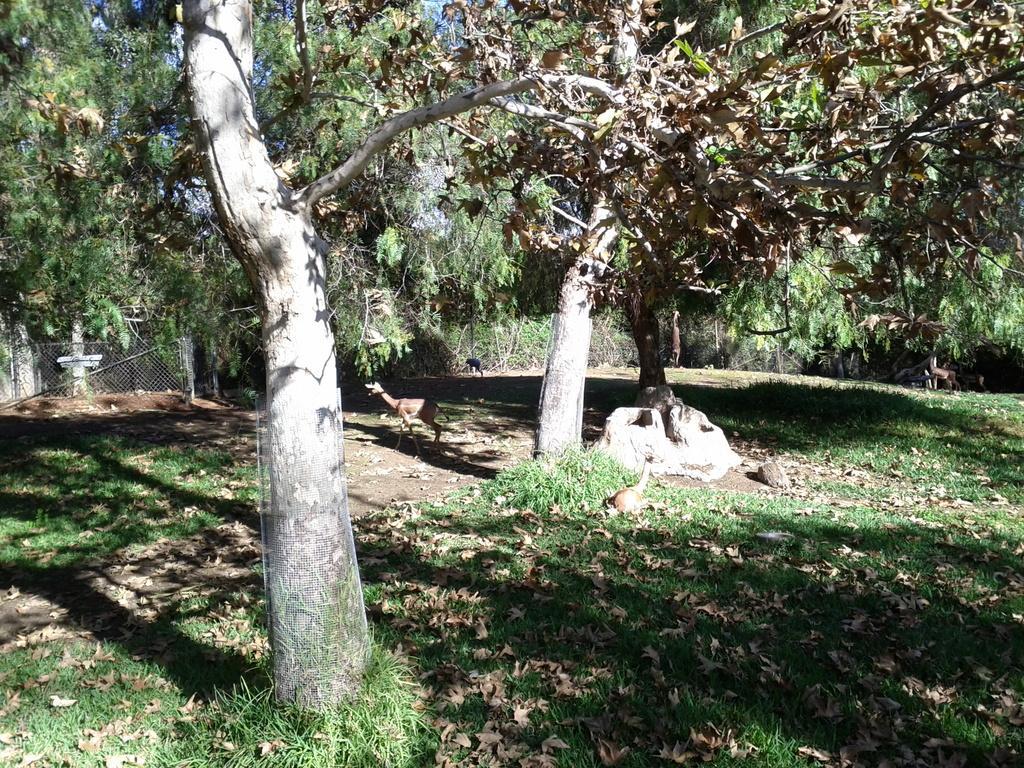Can you describe this image briefly? In this image we can see deer. On the ground there is grass. Also there are dried leaves. And there are many trees. In the back there is a mesh fencing. 